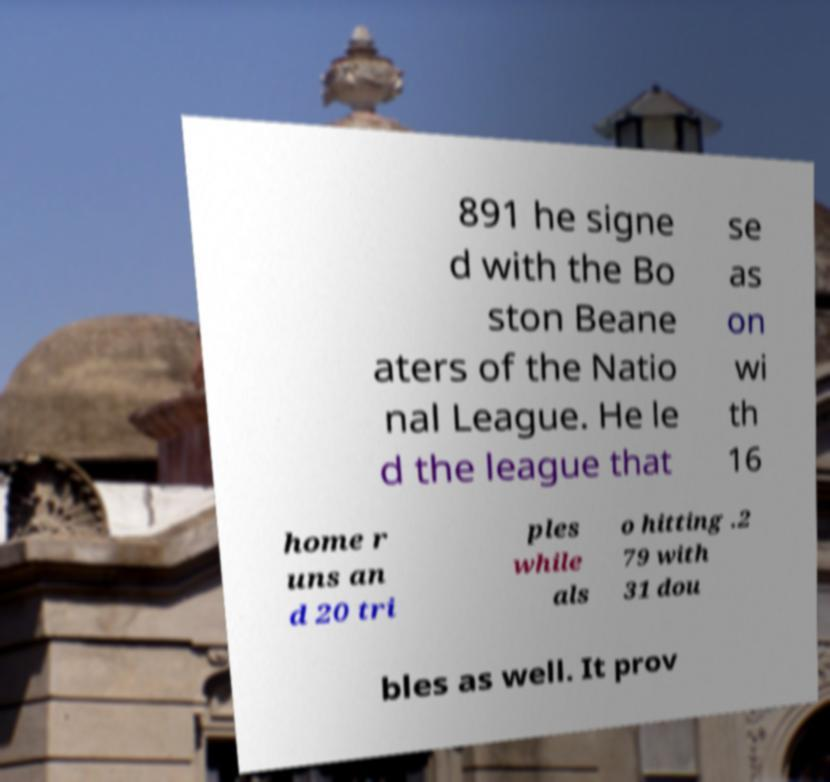Please read and relay the text visible in this image. What does it say? 891 he signe d with the Bo ston Beane aters of the Natio nal League. He le d the league that se as on wi th 16 home r uns an d 20 tri ples while als o hitting .2 79 with 31 dou bles as well. It prov 